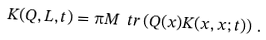Convert formula to latex. <formula><loc_0><loc_0><loc_500><loc_500>K ( Q , L , t ) = \i M \ t r \left ( Q ( x ) K ( x , x ; t ) \right ) \, .</formula> 